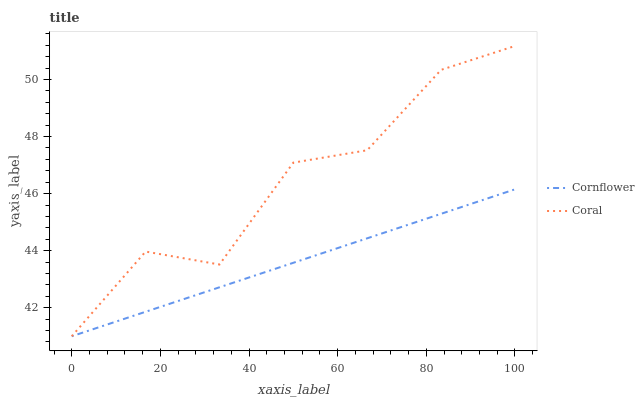Does Cornflower have the minimum area under the curve?
Answer yes or no. Yes. Does Coral have the maximum area under the curve?
Answer yes or no. Yes. Does Coral have the minimum area under the curve?
Answer yes or no. No. Is Cornflower the smoothest?
Answer yes or no. Yes. Is Coral the roughest?
Answer yes or no. Yes. Is Coral the smoothest?
Answer yes or no. No. Does Cornflower have the lowest value?
Answer yes or no. Yes. Does Coral have the highest value?
Answer yes or no. Yes. Does Coral intersect Cornflower?
Answer yes or no. Yes. Is Coral less than Cornflower?
Answer yes or no. No. Is Coral greater than Cornflower?
Answer yes or no. No. 